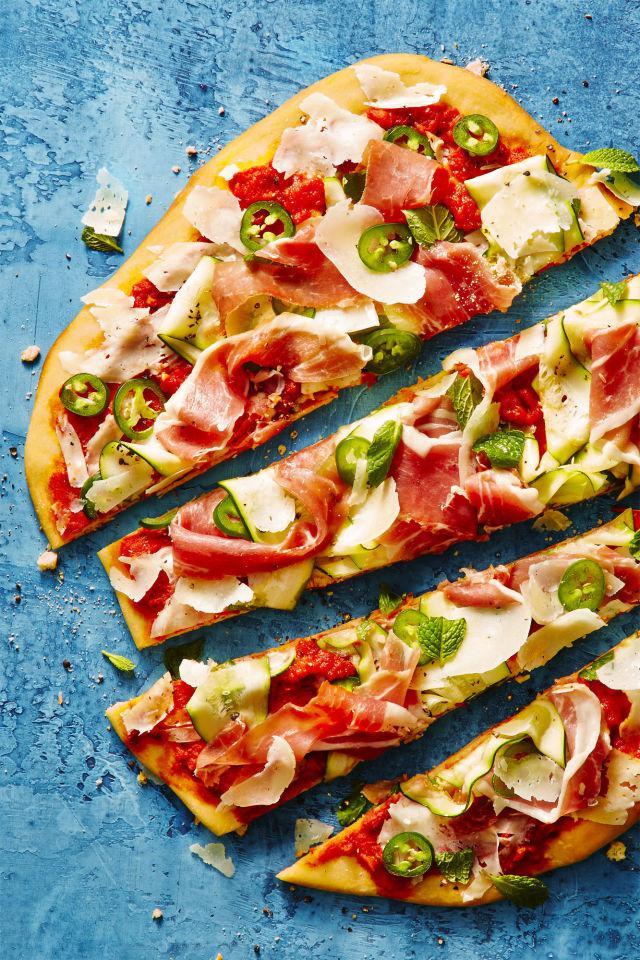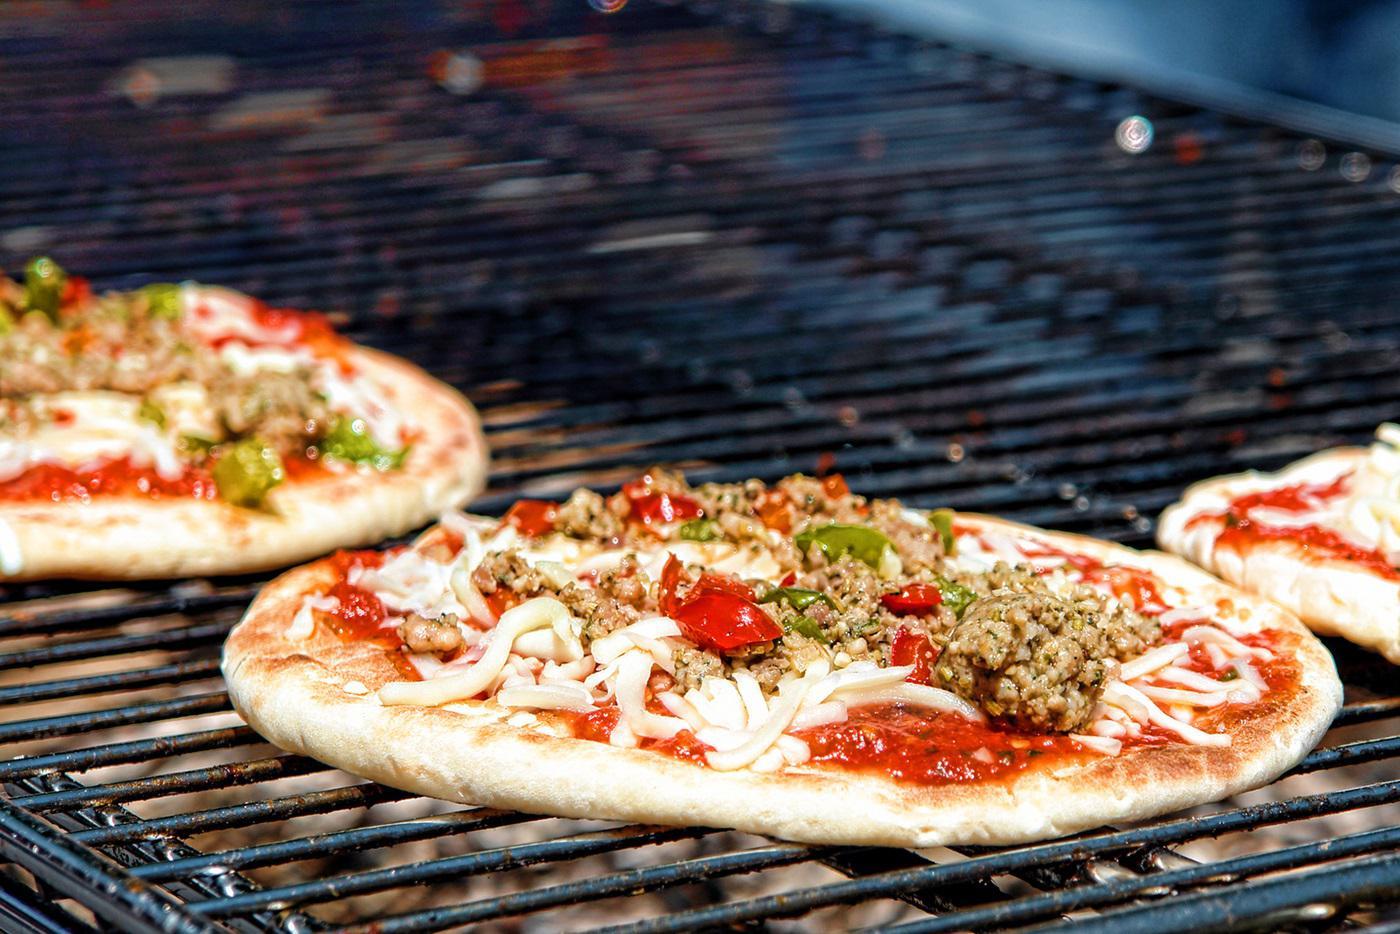The first image is the image on the left, the second image is the image on the right. Considering the images on both sides, is "One image shows multiple round pizzas on a metal grating." valid? Answer yes or no. Yes. The first image is the image on the left, the second image is the image on the right. Given the left and right images, does the statement "Several pizzas sit on a rack in one of the images." hold true? Answer yes or no. Yes. 